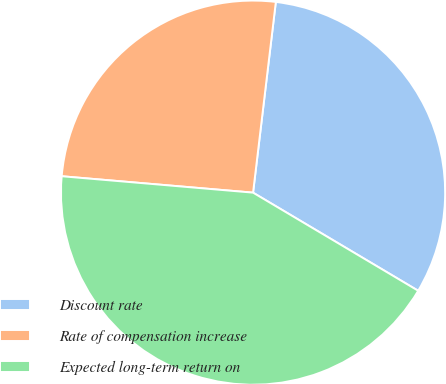Convert chart to OTSL. <chart><loc_0><loc_0><loc_500><loc_500><pie_chart><fcel>Discount rate<fcel>Rate of compensation increase<fcel>Expected long-term return on<nl><fcel>31.64%<fcel>25.53%<fcel>42.83%<nl></chart> 